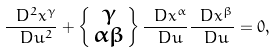<formula> <loc_0><loc_0><loc_500><loc_500>\frac { \ D ^ { 2 } x ^ { \gamma } } { \ D u ^ { 2 } } + \left \{ \begin{smallmatrix} \gamma \\ \alpha \beta \end{smallmatrix} \right \} \frac { \ D x ^ { \alpha } } { \ D u } \frac { \ D x ^ { \beta } } { \ D u } = 0 ,</formula> 